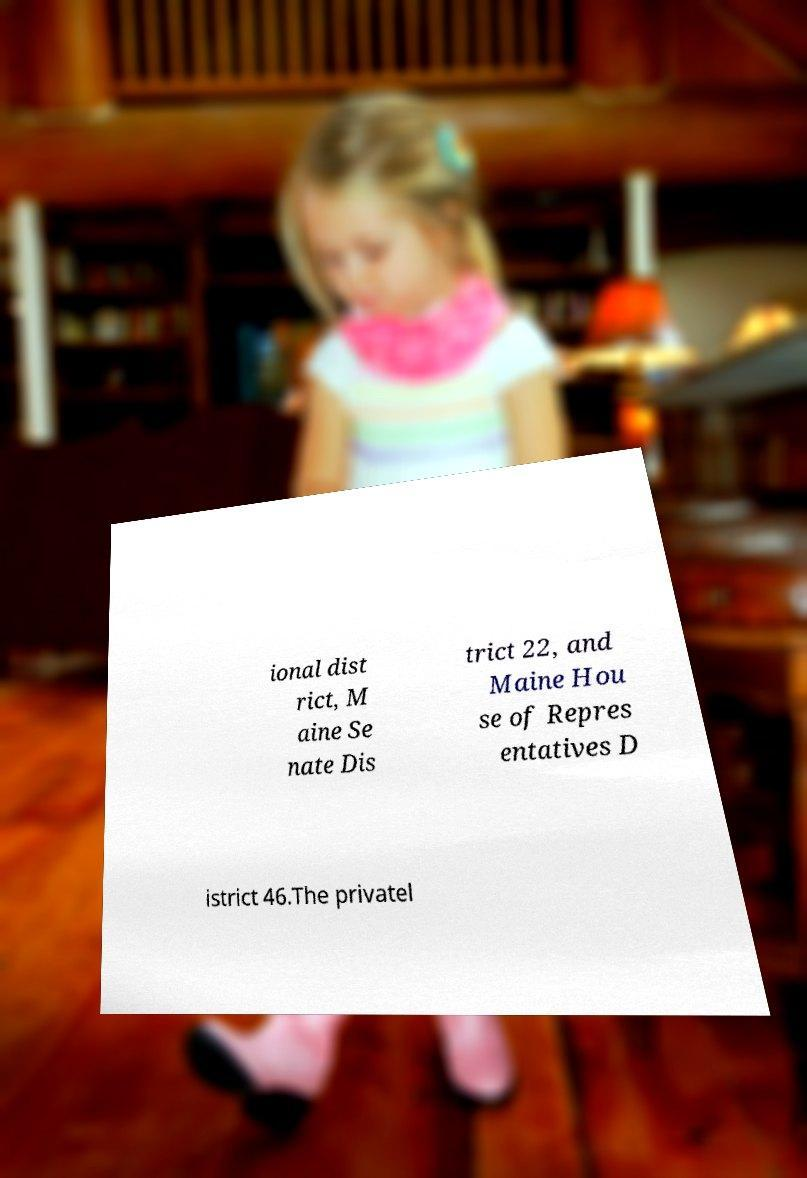Please read and relay the text visible in this image. What does it say? ional dist rict, M aine Se nate Dis trict 22, and Maine Hou se of Repres entatives D istrict 46.The privatel 